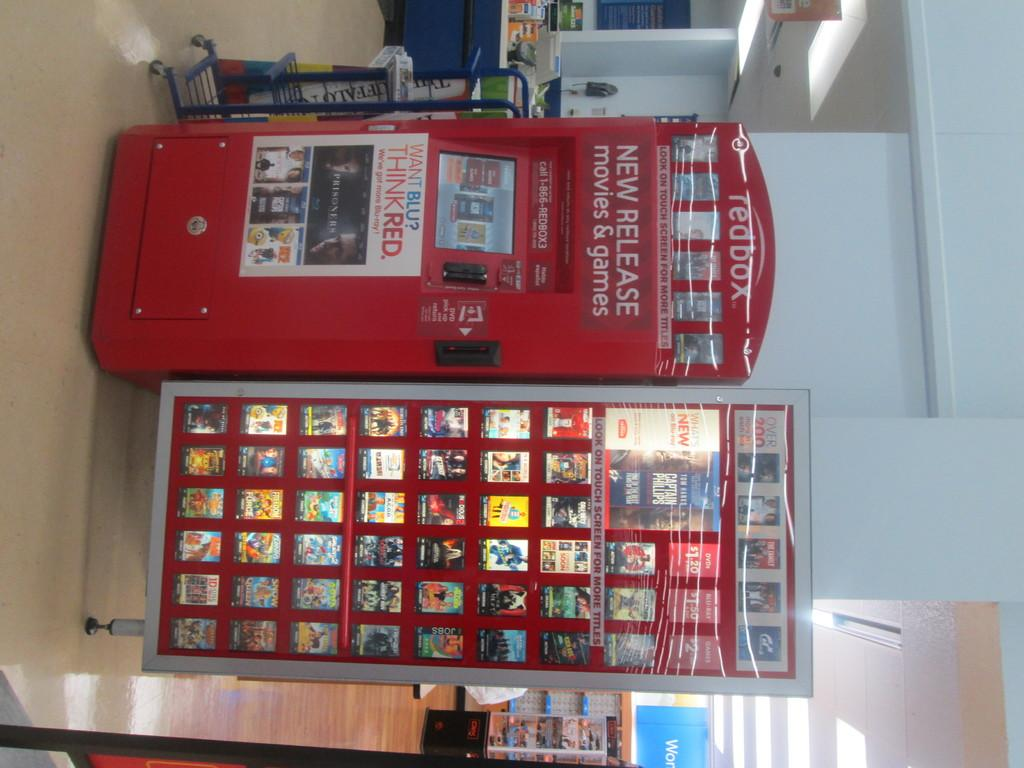<image>
Provide a brief description of the given image. a redbox item that has many movies on it 